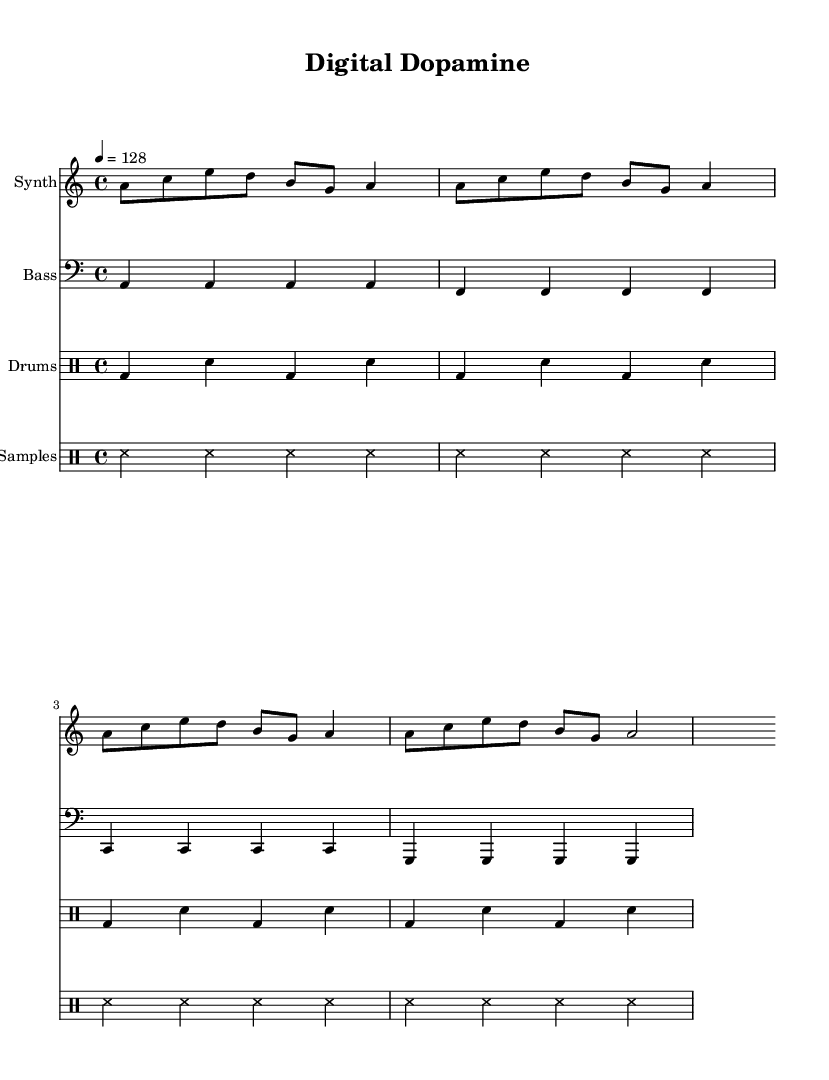What is the key signature of this music? The key signature shows one flat, which indicates the use of the A minor scale. A minor shares the same key signature as C major, which has no sharps or flats.
Answer: A minor What is the time signature of this piece? The time signature is located at the beginning of the score, indicated by the numbers above a horizontal line. Here, it shows four beats in each measure, hence it is in 4/4 time.
Answer: 4/4 What tempo is indicated for this music? The tempo marking is specified in the score with the number 128, which indicates the beats per minute for the piece. It is indicated as "4 = 128," meaning the quarter note gets 128 beats per minute.
Answer: 128 How many measures are there in the synth part? Counting the vertical lines that separate the measures in the synth staff, there are a total of eight measures presented in this part of the score.
Answer: Eight What type of percussion is used for the "Samples" part? The "Samples" part is notated with 'ss' which indicates the sound samples derived from social media notifications. This abbreviation represents the specific type of sound effect used in dance music.
Answer: Sound samples What is the repeated rhythmic pattern in the bass part? Analyzing the bass part, the pattern includes four quarter notes repeated constantly as 'a' on the first measure, followed by 'f', 'c', and 'g' in subsequent measures. This creates a steady rhythmic foundation typical in dance music.
Answer: A, F, C, G 